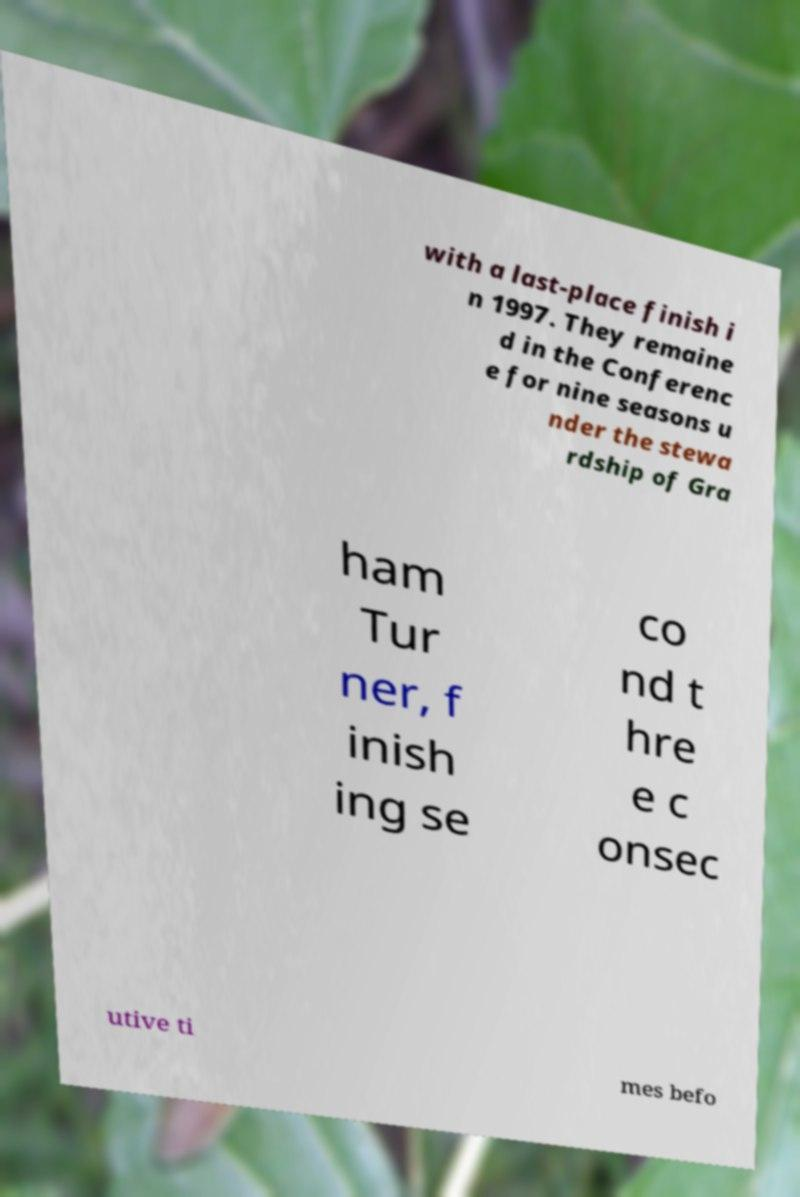Please identify and transcribe the text found in this image. with a last-place finish i n 1997. They remaine d in the Conferenc e for nine seasons u nder the stewa rdship of Gra ham Tur ner, f inish ing se co nd t hre e c onsec utive ti mes befo 